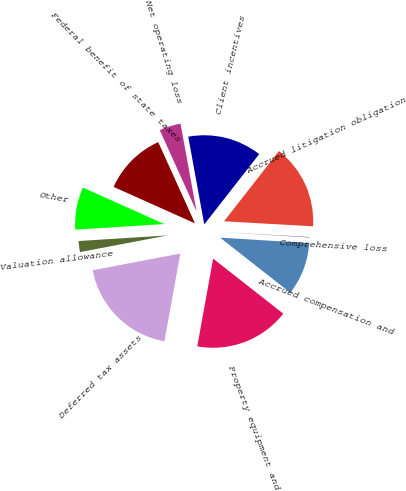Convert chart to OTSL. <chart><loc_0><loc_0><loc_500><loc_500><pie_chart><fcel>Accrued compensation and<fcel>Comprehensive loss<fcel>Accrued litigation obligation<fcel>Client incentives<fcel>Net operating loss<fcel>Federal benefit of state taxes<fcel>Other<fcel>Valuation allowance<fcel>Deferred tax assets<fcel>Property equipment and<nl><fcel>9.62%<fcel>0.08%<fcel>15.34%<fcel>13.43%<fcel>3.89%<fcel>11.53%<fcel>7.71%<fcel>1.99%<fcel>19.16%<fcel>17.25%<nl></chart> 